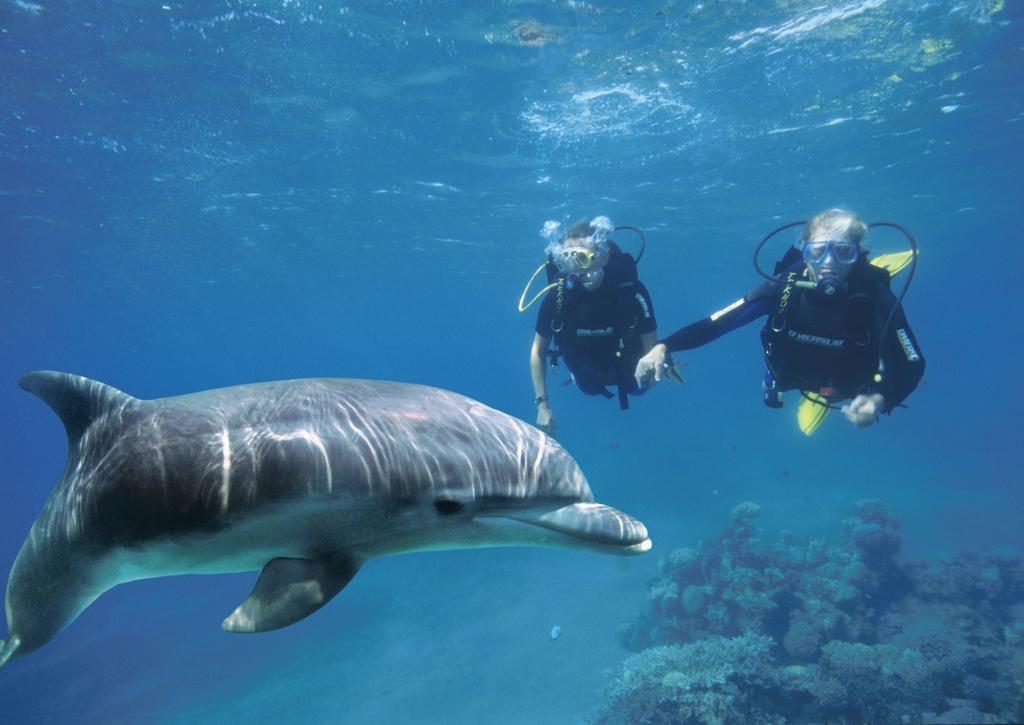How many people are in the image? There are two persons in the image. What are the persons wearing? Both persons are wearing the same dress. What activity are the persons engaged in? The persons are doing water diving. What other animal or creature is present in the image? There is a dolphin in the image. What type of vegetation can be seen in the image? Plants are visible in the bottom right corner of the image. What type of coal is being used to fuel the school in the image? There is no school or coal present in the image; it features two persons in water diving attire, a dolphin, and plants. How can one join the persons in the image for water diving? The image is a static representation and does not depict an actual event or activity that one can join. 